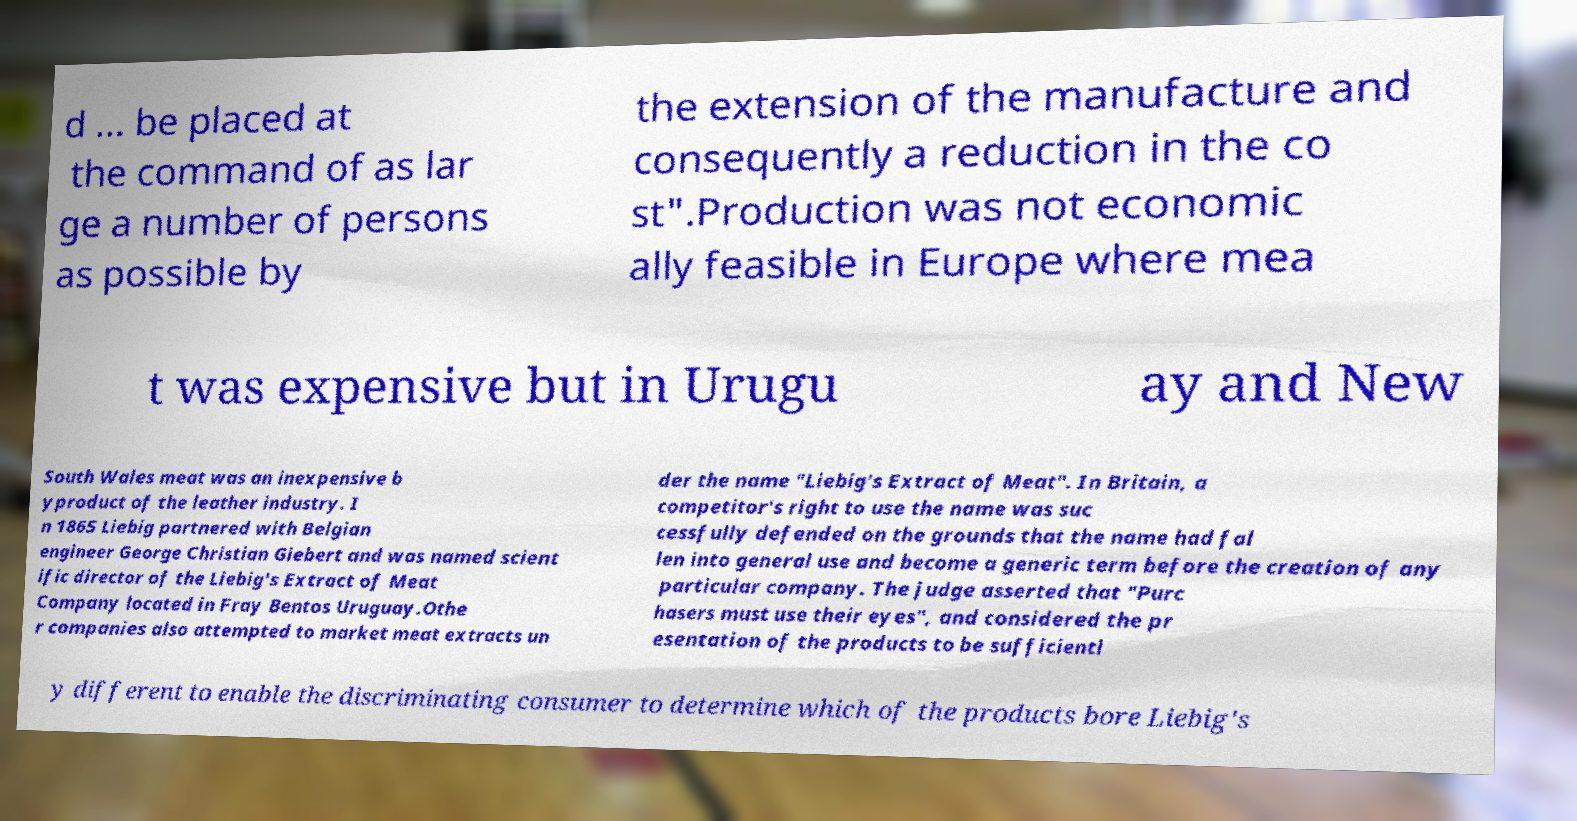There's text embedded in this image that I need extracted. Can you transcribe it verbatim? d ... be placed at the command of as lar ge a number of persons as possible by the extension of the manufacture and consequently a reduction in the co st".Production was not economic ally feasible in Europe where mea t was expensive but in Urugu ay and New South Wales meat was an inexpensive b yproduct of the leather industry. I n 1865 Liebig partnered with Belgian engineer George Christian Giebert and was named scient ific director of the Liebig's Extract of Meat Company located in Fray Bentos Uruguay.Othe r companies also attempted to market meat extracts un der the name "Liebig's Extract of Meat". In Britain, a competitor's right to use the name was suc cessfully defended on the grounds that the name had fal len into general use and become a generic term before the creation of any particular company. The judge asserted that "Purc hasers must use their eyes", and considered the pr esentation of the products to be sufficientl y different to enable the discriminating consumer to determine which of the products bore Liebig's 